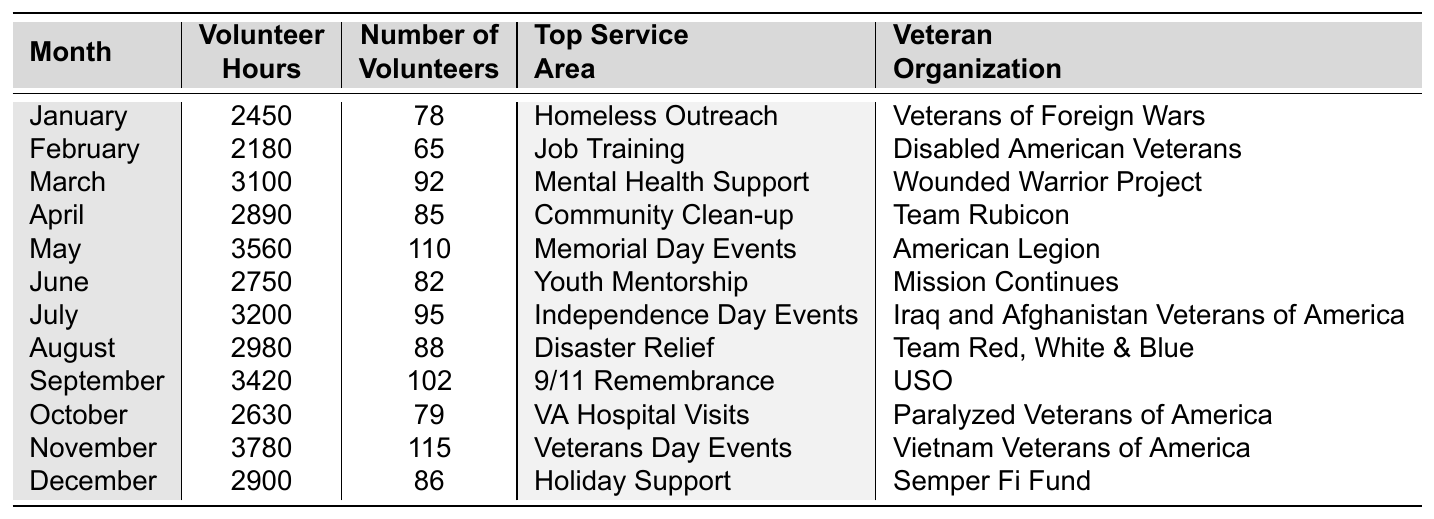What month had the highest number of volunteer hours? By reviewing the "Volunteer Hours" column, I find that November has the highest value of 3780 hours.
Answer: November How many volunteer hours were contributed in March? The table shows that the "Volunteer Hours" for March is 3100.
Answer: 3100 Which organization contributed the most volunteer hours in May? The "Veteran Organization" for May is the American Legion, which contributed 3560 hours.
Answer: American Legion What is the average number of volunteers per month? Adding the number of volunteers from each month (78 + 65 + 92 + 85 + 110 + 82 + 95 + 88 + 102 + 79 + 115 + 86) gives 1,026. Dividing by the number of months (12), the average is 1,026 / 12 = 85.5 or approximately 86.
Answer: 86 Did any month see fewer than 2500 volunteer hours? By checking the "Volunteer Hours" column, January (2450) and February (2180) both have fewer than 2500 hours. Therefore, the answer is yes.
Answer: Yes What was the top service area for volunteer efforts in April? In April, the top service area listed is "Community Clean-up."
Answer: Community Clean-up How many more volunteer hours were contributed in November compared to January? The difference in hours is 3780 (November) - 2450 (January) = 1330 hours more in November.
Answer: 1330 What organization had the least number of volunteers in February? The number of volunteers in February is 65, and it's associated with the Disabled American Veterans organization.
Answer: Disabled American Veterans What is the total number of volunteer hours contributed from June to August? The total for June (2750) + July (3200) + August (2980) equals 2750 + 3200 + 2980 = 8930 hours.
Answer: 8930 Which month had the highest number of volunteers? By reviewing the "Number of Volunteers" column, I see that November had the highest at 115 volunteers.
Answer: November 